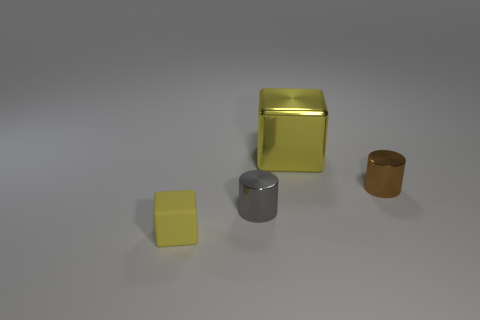How does the lighting affect the appearance of the objects? The lighting in the image is soft and diffused, coming from above and casting gentle shadows directly under the objects. This choice of lighting accentuates the textures of the objects, highlighting their matte finish, and allows the colors – yellow, silver, gold, and brown – to appear true to life. It creates an atmosphere of serenity and manifests the contours and forms of each object without harsh reflections or overexposure. 